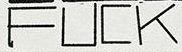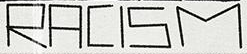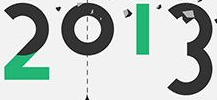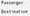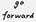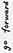Read the text content from these images in order, separated by a semicolon. FUCK; RACISM; 2013; #; #; # 